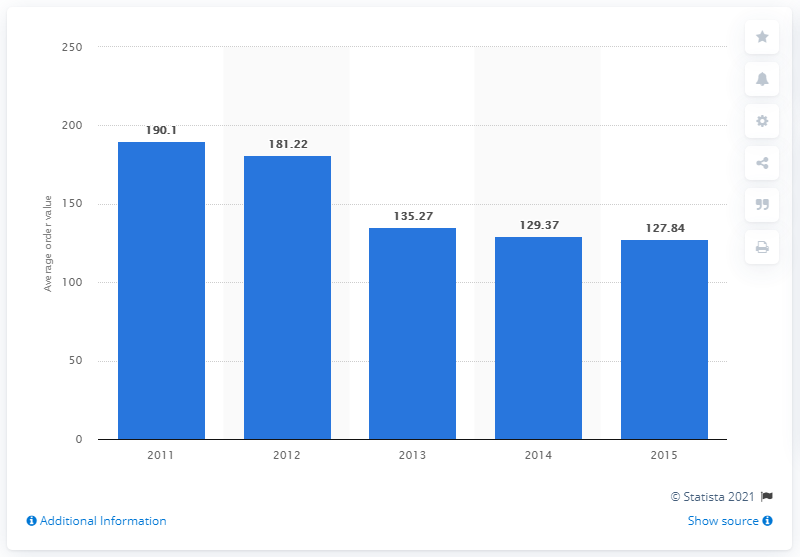Identify some key points in this picture. The average online order value on Black Friday 2015 was $127.84. 